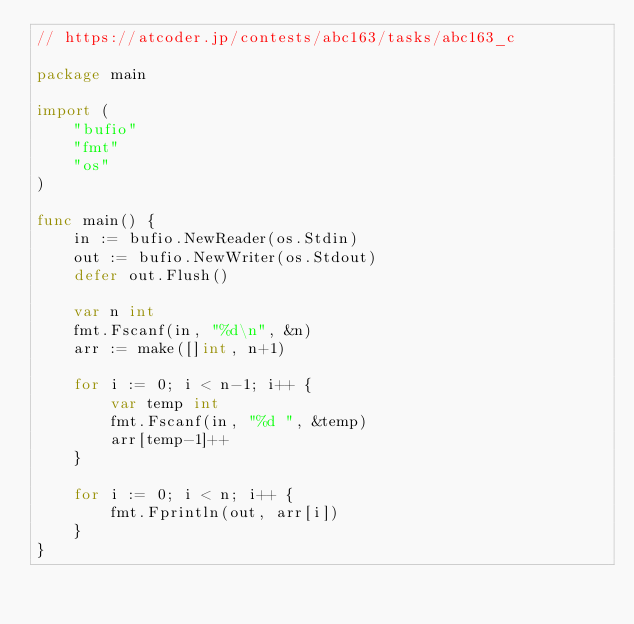<code> <loc_0><loc_0><loc_500><loc_500><_Go_>// https://atcoder.jp/contests/abc163/tasks/abc163_c

package main

import (
	"bufio"
	"fmt"
	"os"
)

func main() {
	in := bufio.NewReader(os.Stdin)
	out := bufio.NewWriter(os.Stdout)
	defer out.Flush()

	var n int
	fmt.Fscanf(in, "%d\n", &n)
	arr := make([]int, n+1)

	for i := 0; i < n-1; i++ {
		var temp int
		fmt.Fscanf(in, "%d ", &temp)
		arr[temp-1]++
	}

	for i := 0; i < n; i++ {
		fmt.Fprintln(out, arr[i])
	}
}
</code> 